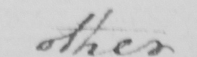Transcribe the text shown in this historical manuscript line. other 